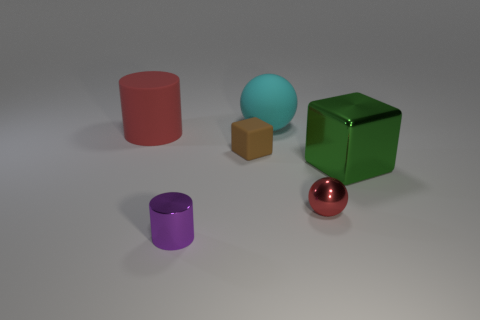Add 2 big yellow matte spheres. How many objects exist? 8 Subtract all spheres. How many objects are left? 4 Add 4 green metallic things. How many green metallic things are left? 5 Add 5 large green metal cubes. How many large green metal cubes exist? 6 Subtract 0 cyan blocks. How many objects are left? 6 Subtract all large cyan cylinders. Subtract all rubber cylinders. How many objects are left? 5 